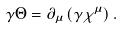<formula> <loc_0><loc_0><loc_500><loc_500>\gamma \Theta = \partial _ { \mu } \left ( \gamma \chi ^ { \mu } \right ) .</formula> 